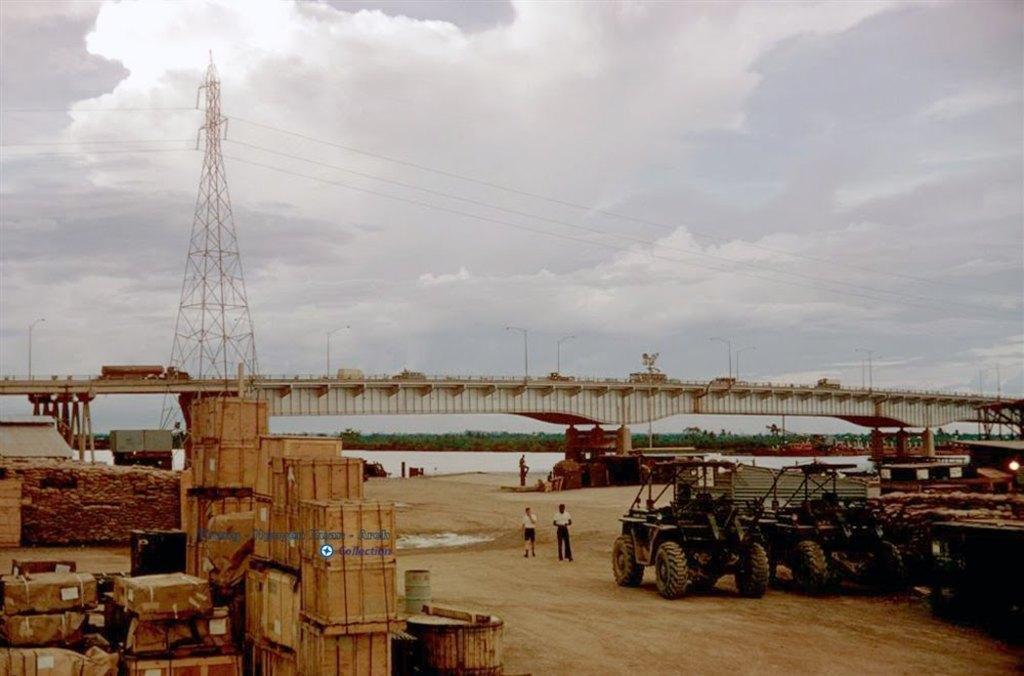How would you summarize this image in a sentence or two? In this picture there are vehicles on the right side of the image. On the left side of the image there are wooden boxes and buildings. At the back there is a bridge and there are trees and there is a tower and there are wires on the tower. In the middle of the image there are two persons. On the bridge there are vehicles and poles. At the top there are clouds. At the bottom there is water. 